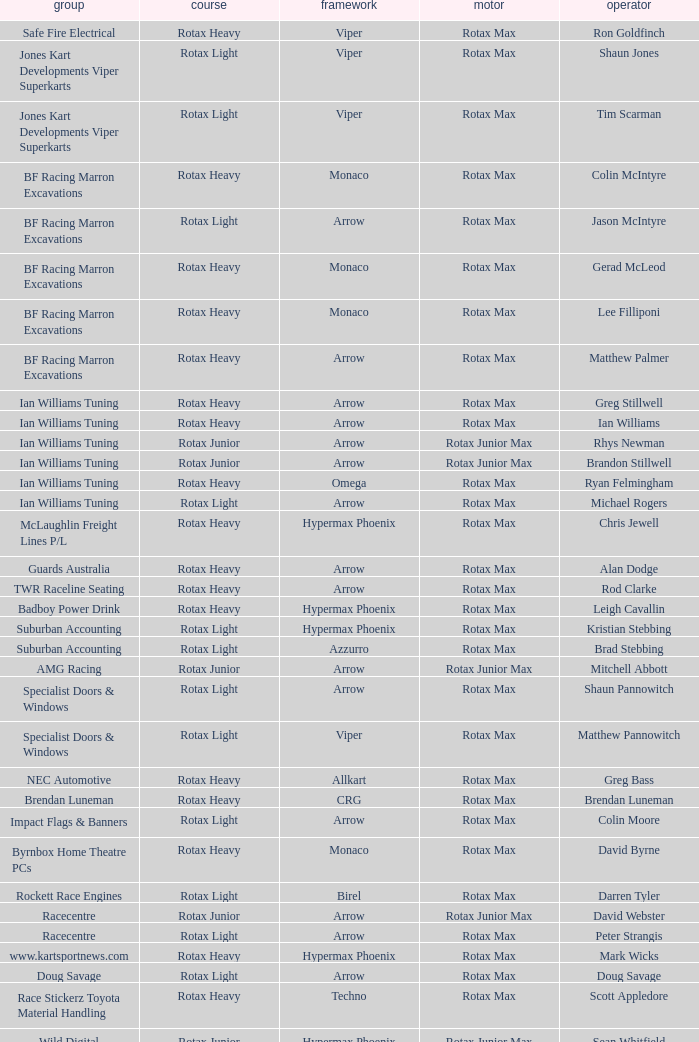Which team does Colin Moore drive for? Impact Flags & Banners. Parse the full table. {'header': ['group', 'course', 'framework', 'motor', 'operator'], 'rows': [['Safe Fire Electrical', 'Rotax Heavy', 'Viper', 'Rotax Max', 'Ron Goldfinch'], ['Jones Kart Developments Viper Superkarts', 'Rotax Light', 'Viper', 'Rotax Max', 'Shaun Jones'], ['Jones Kart Developments Viper Superkarts', 'Rotax Light', 'Viper', 'Rotax Max', 'Tim Scarman'], ['BF Racing Marron Excavations', 'Rotax Heavy', 'Monaco', 'Rotax Max', 'Colin McIntyre'], ['BF Racing Marron Excavations', 'Rotax Light', 'Arrow', 'Rotax Max', 'Jason McIntyre'], ['BF Racing Marron Excavations', 'Rotax Heavy', 'Monaco', 'Rotax Max', 'Gerad McLeod'], ['BF Racing Marron Excavations', 'Rotax Heavy', 'Monaco', 'Rotax Max', 'Lee Filliponi'], ['BF Racing Marron Excavations', 'Rotax Heavy', 'Arrow', 'Rotax Max', 'Matthew Palmer'], ['Ian Williams Tuning', 'Rotax Heavy', 'Arrow', 'Rotax Max', 'Greg Stillwell'], ['Ian Williams Tuning', 'Rotax Heavy', 'Arrow', 'Rotax Max', 'Ian Williams'], ['Ian Williams Tuning', 'Rotax Junior', 'Arrow', 'Rotax Junior Max', 'Rhys Newman'], ['Ian Williams Tuning', 'Rotax Junior', 'Arrow', 'Rotax Junior Max', 'Brandon Stillwell'], ['Ian Williams Tuning', 'Rotax Heavy', 'Omega', 'Rotax Max', 'Ryan Felmingham'], ['Ian Williams Tuning', 'Rotax Light', 'Arrow', 'Rotax Max', 'Michael Rogers'], ['McLaughlin Freight Lines P/L', 'Rotax Heavy', 'Hypermax Phoenix', 'Rotax Max', 'Chris Jewell'], ['Guards Australia', 'Rotax Heavy', 'Arrow', 'Rotax Max', 'Alan Dodge'], ['TWR Raceline Seating', 'Rotax Heavy', 'Arrow', 'Rotax Max', 'Rod Clarke'], ['Badboy Power Drink', 'Rotax Heavy', 'Hypermax Phoenix', 'Rotax Max', 'Leigh Cavallin'], ['Suburban Accounting', 'Rotax Light', 'Hypermax Phoenix', 'Rotax Max', 'Kristian Stebbing'], ['Suburban Accounting', 'Rotax Light', 'Azzurro', 'Rotax Max', 'Brad Stebbing'], ['AMG Racing', 'Rotax Junior', 'Arrow', 'Rotax Junior Max', 'Mitchell Abbott'], ['Specialist Doors & Windows', 'Rotax Light', 'Arrow', 'Rotax Max', 'Shaun Pannowitch'], ['Specialist Doors & Windows', 'Rotax Light', 'Viper', 'Rotax Max', 'Matthew Pannowitch'], ['NEC Automotive', 'Rotax Heavy', 'Allkart', 'Rotax Max', 'Greg Bass'], ['Brendan Luneman', 'Rotax Heavy', 'CRG', 'Rotax Max', 'Brendan Luneman'], ['Impact Flags & Banners', 'Rotax Light', 'Arrow', 'Rotax Max', 'Colin Moore'], ['Byrnbox Home Theatre PCs', 'Rotax Heavy', 'Monaco', 'Rotax Max', 'David Byrne'], ['Rockett Race Engines', 'Rotax Light', 'Birel', 'Rotax Max', 'Darren Tyler'], ['Racecentre', 'Rotax Junior', 'Arrow', 'Rotax Junior Max', 'David Webster'], ['Racecentre', 'Rotax Light', 'Arrow', 'Rotax Max', 'Peter Strangis'], ['www.kartsportnews.com', 'Rotax Heavy', 'Hypermax Phoenix', 'Rotax Max', 'Mark Wicks'], ['Doug Savage', 'Rotax Light', 'Arrow', 'Rotax Max', 'Doug Savage'], ['Race Stickerz Toyota Material Handling', 'Rotax Heavy', 'Techno', 'Rotax Max', 'Scott Appledore'], ['Wild Digital', 'Rotax Junior', 'Hypermax Phoenix', 'Rotax Junior Max', 'Sean Whitfield'], ['John Bartlett', 'Rotax Heavy', 'Hypermax Phoenix', 'Rotax Max', 'John Bartlett']]} 